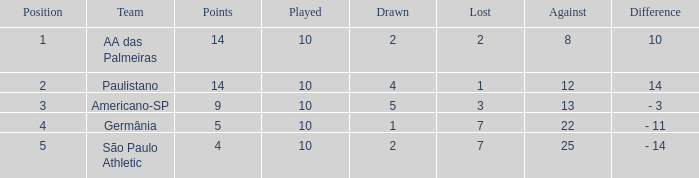When the played count is over 10, what is the smallest against figure? None. 